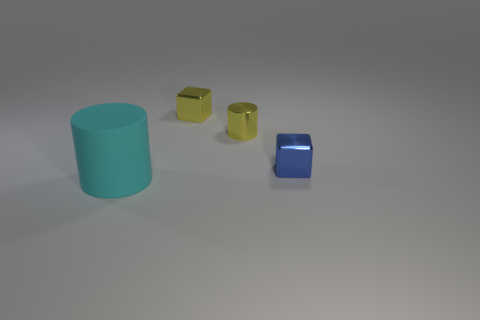Is the number of rubber cylinders on the left side of the large cyan matte thing less than the number of cyan cylinders?
Keep it short and to the point. Yes. What is the material of the block that is behind the small blue thing?
Your response must be concise. Metal. How many other objects are the same size as the cyan cylinder?
Give a very brief answer. 0. Are there fewer small purple things than large cyan rubber cylinders?
Make the answer very short. Yes. The blue metal object is what shape?
Give a very brief answer. Cube. There is a cylinder that is behind the big cyan object; is its color the same as the large cylinder?
Your answer should be compact. No. What shape is the object that is in front of the yellow cylinder and left of the blue shiny cube?
Keep it short and to the point. Cylinder. What color is the cylinder that is in front of the small blue cube?
Your answer should be very brief. Cyan. Is there anything else that has the same color as the rubber thing?
Your answer should be very brief. No. Do the blue shiny object and the matte cylinder have the same size?
Offer a very short reply. No. 